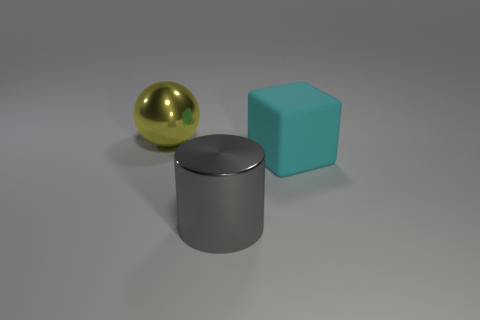Subtract all brown cylinders. Subtract all red blocks. How many cylinders are left? 1 Add 3 small red rubber cubes. How many objects exist? 6 Subtract all cylinders. How many objects are left? 2 Subtract 0 red blocks. How many objects are left? 3 Subtract all big cyan cubes. Subtract all large red cylinders. How many objects are left? 2 Add 3 yellow metallic things. How many yellow metallic things are left? 4 Add 3 big cylinders. How many big cylinders exist? 4 